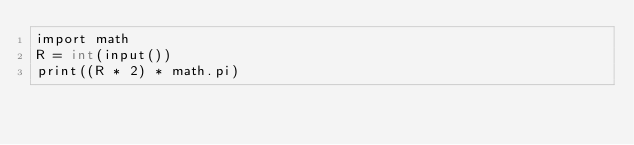<code> <loc_0><loc_0><loc_500><loc_500><_C_>import math
R = int(input())
print((R * 2) * math.pi)</code> 